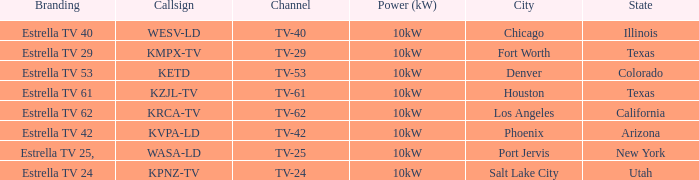List the branding for krca-tv. Estrella TV 62. 